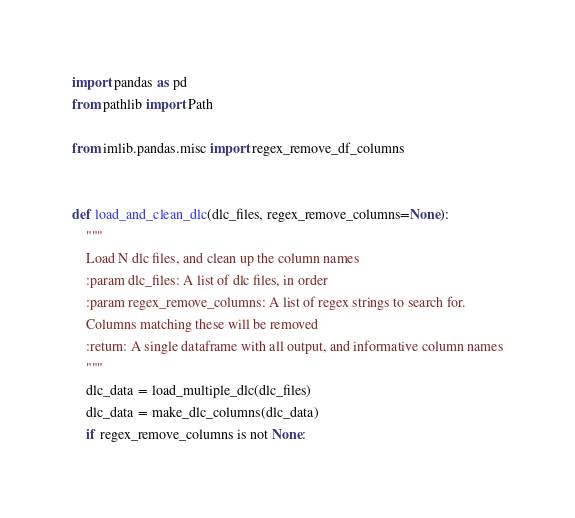<code> <loc_0><loc_0><loc_500><loc_500><_Python_>import pandas as pd
from pathlib import Path

from imlib.pandas.misc import regex_remove_df_columns


def load_and_clean_dlc(dlc_files, regex_remove_columns=None):
    """
    Load N dlc files, and clean up the column names
    :param dlc_files: A list of dlc files, in order
    :param regex_remove_columns: A list of regex strings to search for.
    Columns matching these will be removed
    :return: A single dataframe with all output, and informative column names
    """
    dlc_data = load_multiple_dlc(dlc_files)
    dlc_data = make_dlc_columns(dlc_data)
    if regex_remove_columns is not None:</code> 